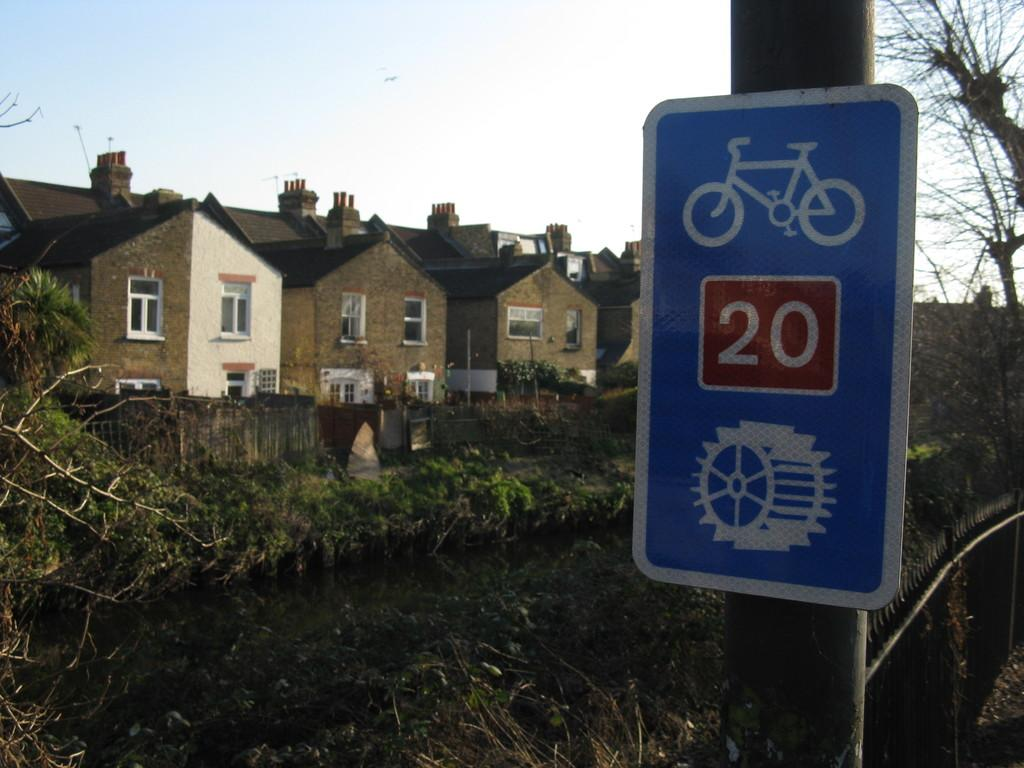<image>
Write a terse but informative summary of the picture. A sign that is blue and has a number 20 in a red box 